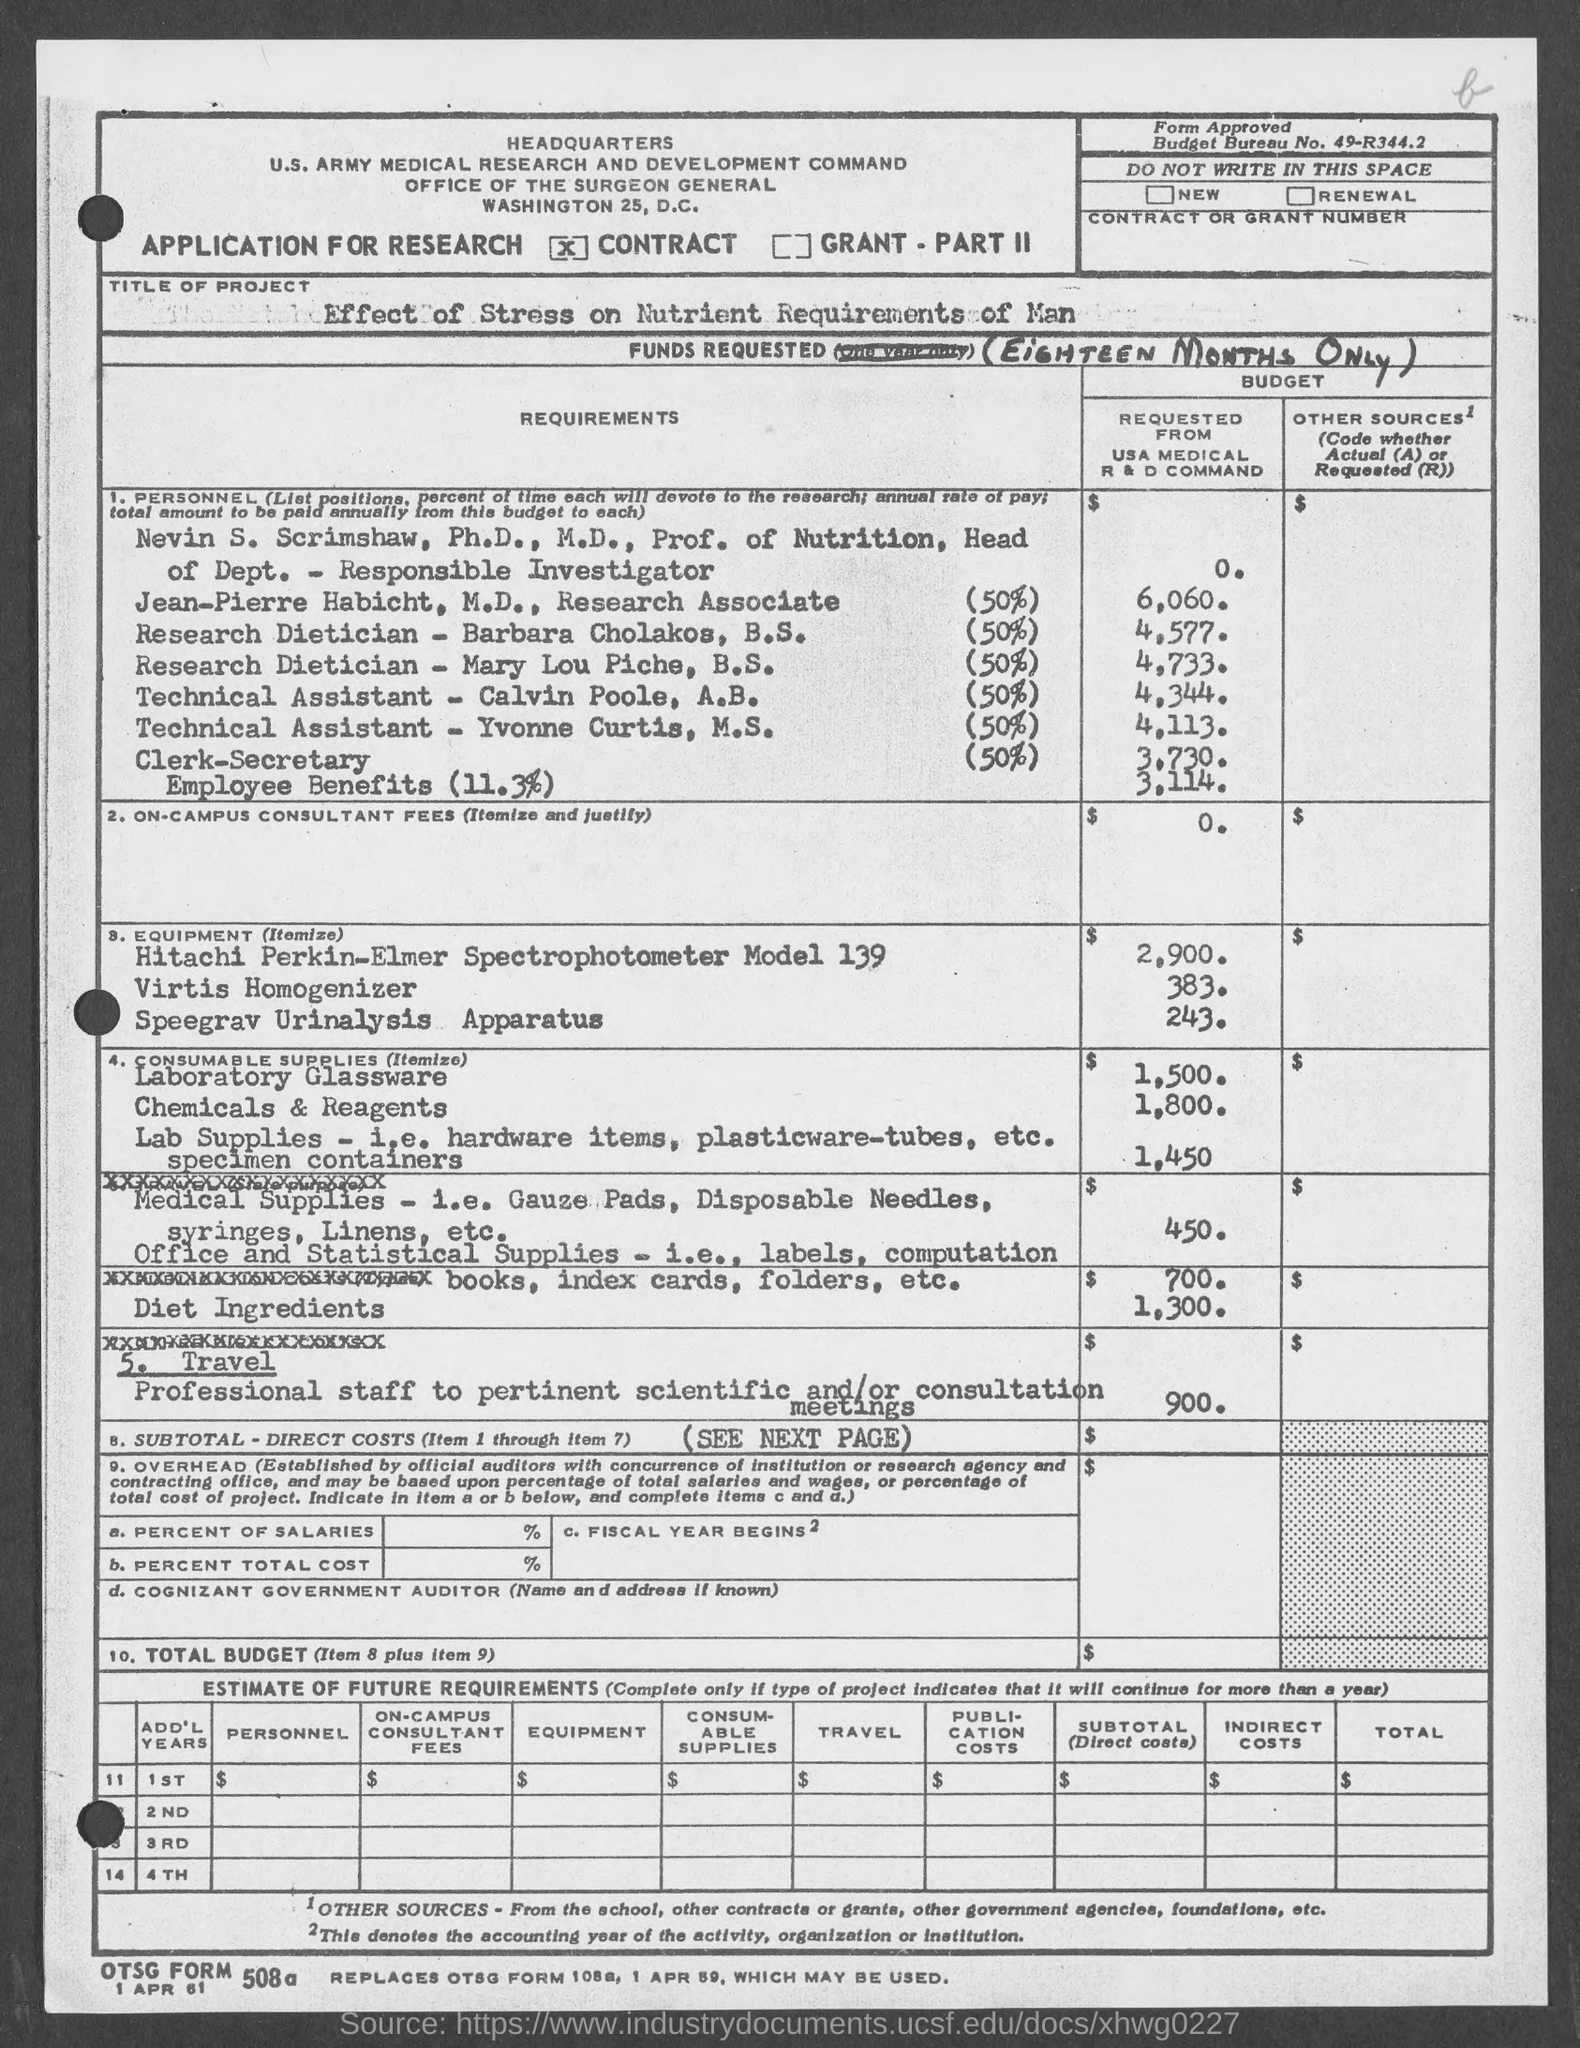Specify some key components in this picture. The project title given in the application is "The Effect of Stress on Nutrient Requirements in Human". 